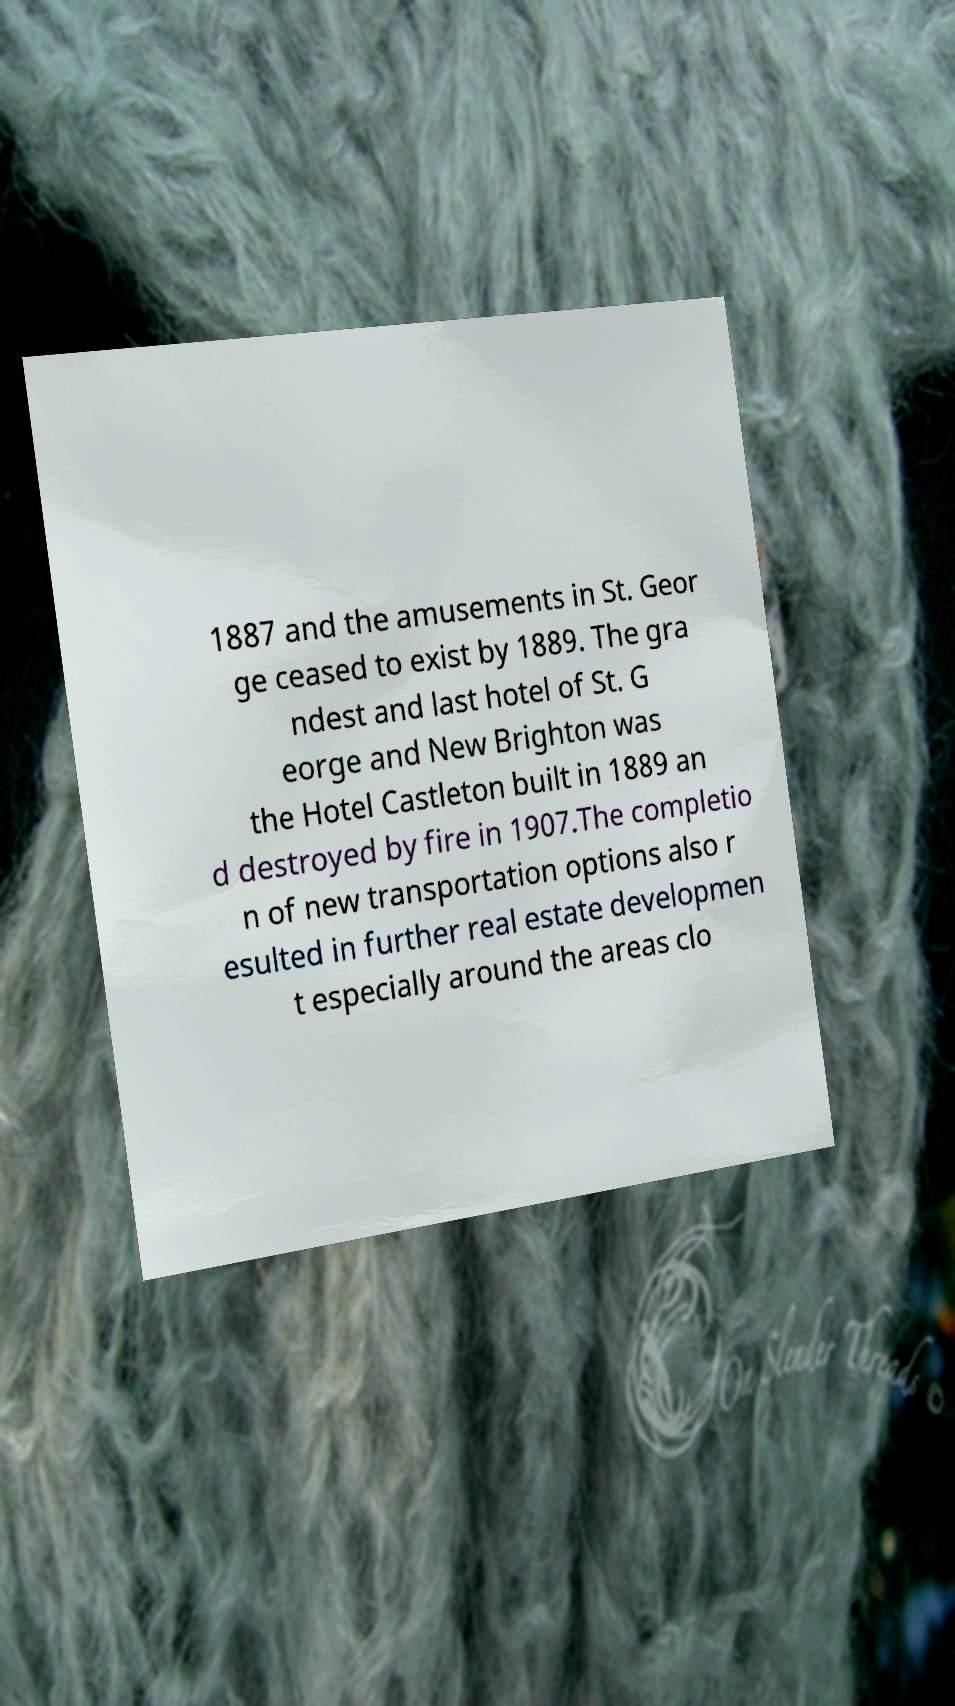What messages or text are displayed in this image? I need them in a readable, typed format. 1887 and the amusements in St. Geor ge ceased to exist by 1889. The gra ndest and last hotel of St. G eorge and New Brighton was the Hotel Castleton built in 1889 an d destroyed by fire in 1907.The completio n of new transportation options also r esulted in further real estate developmen t especially around the areas clo 